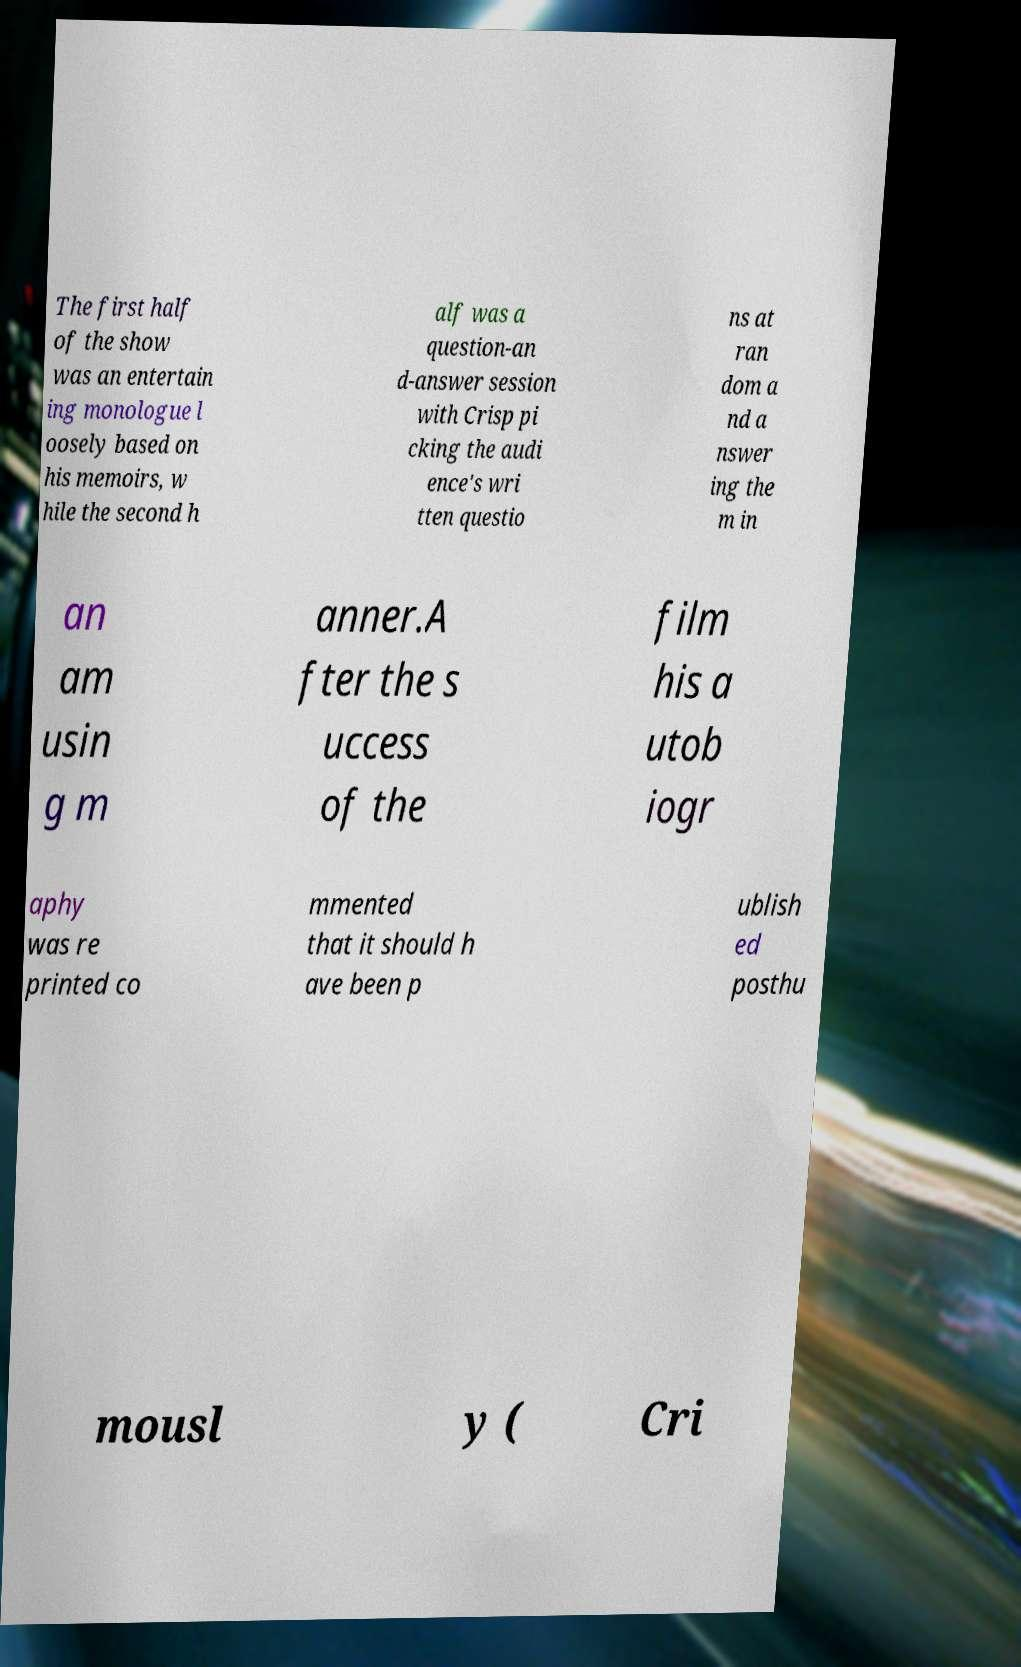Could you assist in decoding the text presented in this image and type it out clearly? The first half of the show was an entertain ing monologue l oosely based on his memoirs, w hile the second h alf was a question-an d-answer session with Crisp pi cking the audi ence's wri tten questio ns at ran dom a nd a nswer ing the m in an am usin g m anner.A fter the s uccess of the film his a utob iogr aphy was re printed co mmented that it should h ave been p ublish ed posthu mousl y ( Cri 